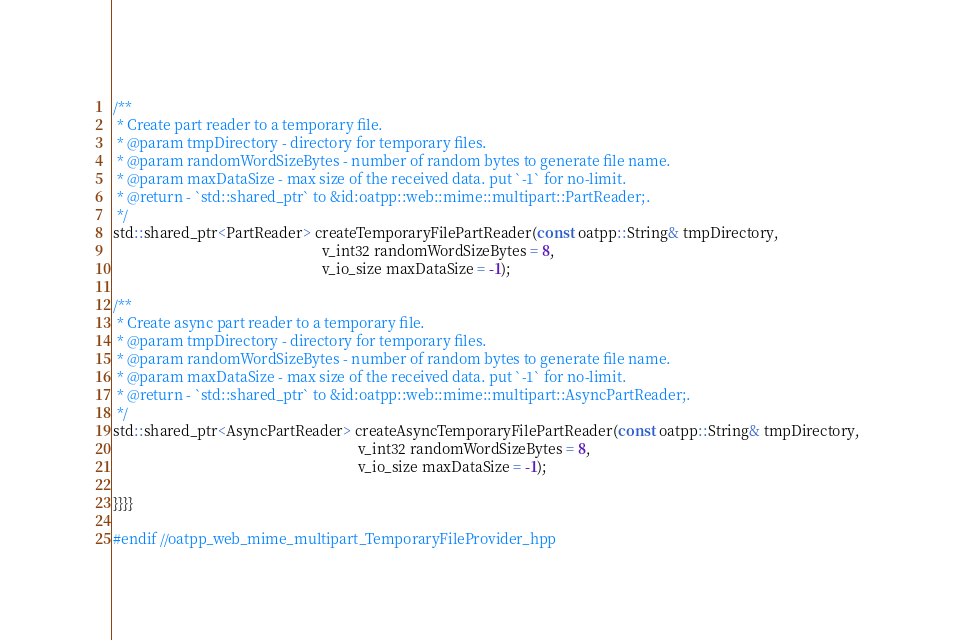Convert code to text. <code><loc_0><loc_0><loc_500><loc_500><_C++_>/**
 * Create part reader to a temporary file.
 * @param tmpDirectory - directory for temporary files.
 * @param randomWordSizeBytes - number of random bytes to generate file name.
 * @param maxDataSize - max size of the received data. put `-1` for no-limit.
 * @return - `std::shared_ptr` to &id:oatpp::web::mime::multipart::PartReader;.
 */
std::shared_ptr<PartReader> createTemporaryFilePartReader(const oatpp::String& tmpDirectory,
                                                          v_int32 randomWordSizeBytes = 8,
                                                          v_io_size maxDataSize = -1);

/**
 * Create async part reader to a temporary file.
 * @param tmpDirectory - directory for temporary files.
 * @param randomWordSizeBytes - number of random bytes to generate file name.
 * @param maxDataSize - max size of the received data. put `-1` for no-limit.
 * @return - `std::shared_ptr` to &id:oatpp::web::mime::multipart::AsyncPartReader;.
 */
std::shared_ptr<AsyncPartReader> createAsyncTemporaryFilePartReader(const oatpp::String& tmpDirectory,
                                                                    v_int32 randomWordSizeBytes = 8,
                                                                    v_io_size maxDataSize = -1);

}}}}

#endif //oatpp_web_mime_multipart_TemporaryFileProvider_hpp
</code> 